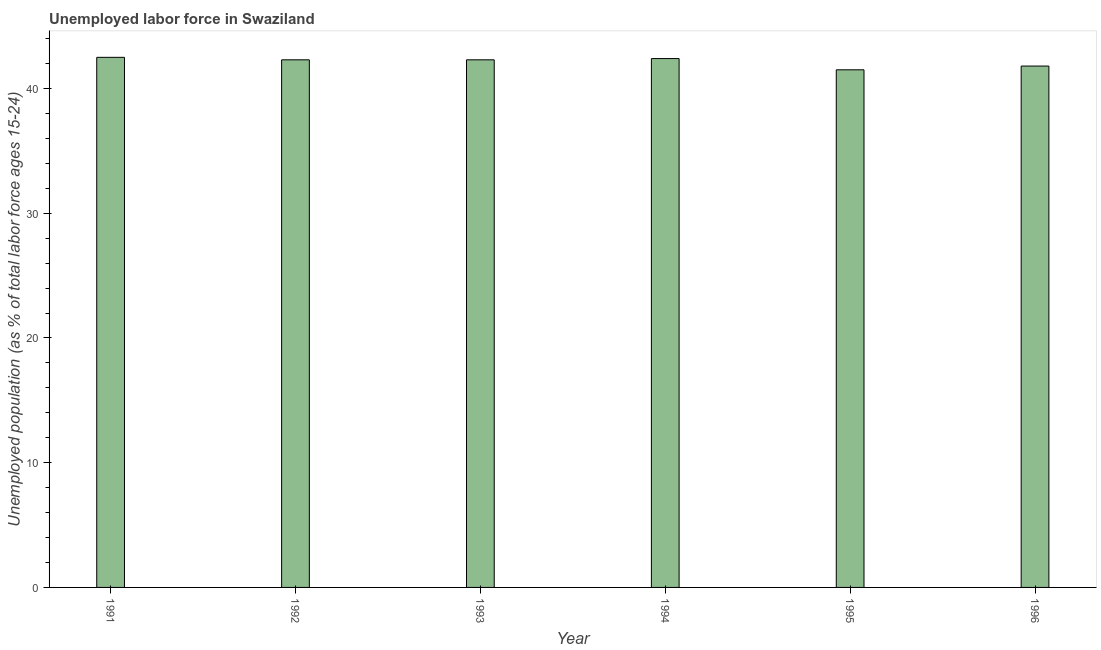Does the graph contain grids?
Provide a short and direct response. No. What is the title of the graph?
Keep it short and to the point. Unemployed labor force in Swaziland. What is the label or title of the X-axis?
Ensure brevity in your answer.  Year. What is the label or title of the Y-axis?
Offer a terse response. Unemployed population (as % of total labor force ages 15-24). What is the total unemployed youth population in 1992?
Make the answer very short. 42.3. Across all years, what is the maximum total unemployed youth population?
Your answer should be compact. 42.5. Across all years, what is the minimum total unemployed youth population?
Provide a succinct answer. 41.5. In which year was the total unemployed youth population maximum?
Keep it short and to the point. 1991. In which year was the total unemployed youth population minimum?
Your answer should be very brief. 1995. What is the sum of the total unemployed youth population?
Provide a short and direct response. 252.8. What is the average total unemployed youth population per year?
Your answer should be very brief. 42.13. What is the median total unemployed youth population?
Your answer should be very brief. 42.3. What is the ratio of the total unemployed youth population in 1992 to that in 1994?
Provide a succinct answer. 1. What is the difference between the highest and the second highest total unemployed youth population?
Offer a terse response. 0.1. Is the sum of the total unemployed youth population in 1993 and 1995 greater than the maximum total unemployed youth population across all years?
Ensure brevity in your answer.  Yes. How many bars are there?
Offer a very short reply. 6. Are all the bars in the graph horizontal?
Ensure brevity in your answer.  No. What is the difference between two consecutive major ticks on the Y-axis?
Provide a short and direct response. 10. Are the values on the major ticks of Y-axis written in scientific E-notation?
Offer a terse response. No. What is the Unemployed population (as % of total labor force ages 15-24) of 1991?
Your answer should be very brief. 42.5. What is the Unemployed population (as % of total labor force ages 15-24) of 1992?
Your response must be concise. 42.3. What is the Unemployed population (as % of total labor force ages 15-24) of 1993?
Give a very brief answer. 42.3. What is the Unemployed population (as % of total labor force ages 15-24) in 1994?
Make the answer very short. 42.4. What is the Unemployed population (as % of total labor force ages 15-24) of 1995?
Your response must be concise. 41.5. What is the Unemployed population (as % of total labor force ages 15-24) of 1996?
Make the answer very short. 41.8. What is the difference between the Unemployed population (as % of total labor force ages 15-24) in 1991 and 1995?
Give a very brief answer. 1. What is the difference between the Unemployed population (as % of total labor force ages 15-24) in 1991 and 1996?
Ensure brevity in your answer.  0.7. What is the difference between the Unemployed population (as % of total labor force ages 15-24) in 1992 and 1994?
Your answer should be very brief. -0.1. What is the difference between the Unemployed population (as % of total labor force ages 15-24) in 1992 and 1995?
Offer a terse response. 0.8. What is the difference between the Unemployed population (as % of total labor force ages 15-24) in 1992 and 1996?
Offer a terse response. 0.5. What is the difference between the Unemployed population (as % of total labor force ages 15-24) in 1993 and 1996?
Make the answer very short. 0.5. What is the ratio of the Unemployed population (as % of total labor force ages 15-24) in 1991 to that in 1993?
Ensure brevity in your answer.  1. What is the ratio of the Unemployed population (as % of total labor force ages 15-24) in 1991 to that in 1994?
Give a very brief answer. 1. What is the ratio of the Unemployed population (as % of total labor force ages 15-24) in 1991 to that in 1995?
Offer a very short reply. 1.02. What is the ratio of the Unemployed population (as % of total labor force ages 15-24) in 1992 to that in 1993?
Provide a succinct answer. 1. What is the ratio of the Unemployed population (as % of total labor force ages 15-24) in 1992 to that in 1994?
Provide a short and direct response. 1. What is the ratio of the Unemployed population (as % of total labor force ages 15-24) in 1992 to that in 1995?
Offer a very short reply. 1.02. What is the ratio of the Unemployed population (as % of total labor force ages 15-24) in 1992 to that in 1996?
Provide a short and direct response. 1.01. What is the ratio of the Unemployed population (as % of total labor force ages 15-24) in 1993 to that in 1994?
Your answer should be very brief. 1. What is the ratio of the Unemployed population (as % of total labor force ages 15-24) in 1994 to that in 1995?
Provide a short and direct response. 1.02. What is the ratio of the Unemployed population (as % of total labor force ages 15-24) in 1994 to that in 1996?
Your answer should be compact. 1.01. What is the ratio of the Unemployed population (as % of total labor force ages 15-24) in 1995 to that in 1996?
Keep it short and to the point. 0.99. 